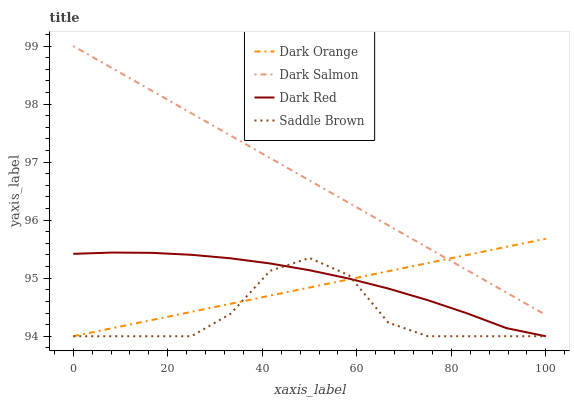Does Saddle Brown have the minimum area under the curve?
Answer yes or no. Yes. Does Dark Salmon have the maximum area under the curve?
Answer yes or no. Yes. Does Dark Orange have the minimum area under the curve?
Answer yes or no. No. Does Dark Orange have the maximum area under the curve?
Answer yes or no. No. Is Dark Orange the smoothest?
Answer yes or no. Yes. Is Saddle Brown the roughest?
Answer yes or no. Yes. Is Dark Salmon the smoothest?
Answer yes or no. No. Is Dark Salmon the roughest?
Answer yes or no. No. Does Saddle Brown have the lowest value?
Answer yes or no. Yes. Does Dark Salmon have the lowest value?
Answer yes or no. No. Does Dark Salmon have the highest value?
Answer yes or no. Yes. Does Dark Orange have the highest value?
Answer yes or no. No. Is Saddle Brown less than Dark Salmon?
Answer yes or no. Yes. Is Dark Salmon greater than Saddle Brown?
Answer yes or no. Yes. Does Dark Red intersect Saddle Brown?
Answer yes or no. Yes. Is Dark Red less than Saddle Brown?
Answer yes or no. No. Is Dark Red greater than Saddle Brown?
Answer yes or no. No. Does Saddle Brown intersect Dark Salmon?
Answer yes or no. No. 